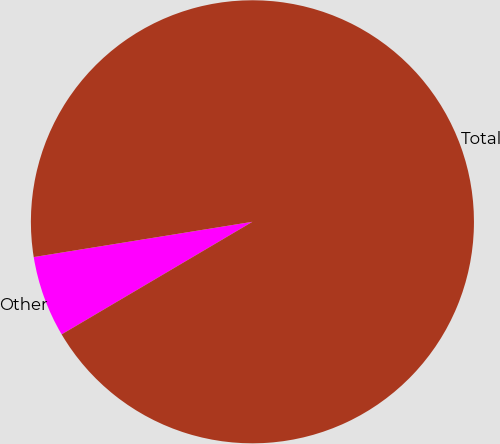Convert chart. <chart><loc_0><loc_0><loc_500><loc_500><pie_chart><fcel>Other<fcel>Total<nl><fcel>5.94%<fcel>94.06%<nl></chart> 